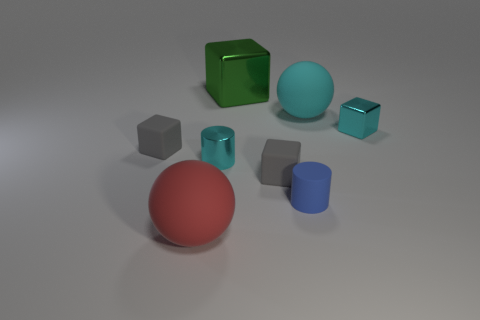There is a red thing that is the same size as the cyan matte sphere; what material is it? rubber 